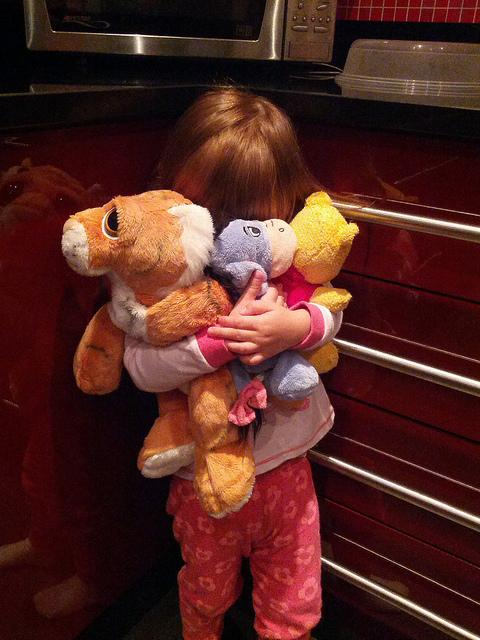What type of animal is the middle toy the child is holding? donkey 